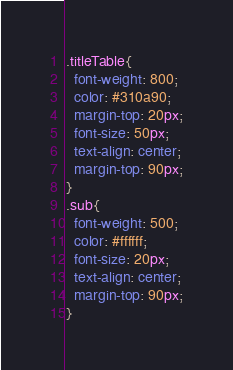<code> <loc_0><loc_0><loc_500><loc_500><_CSS_>.titleTable{
  font-weight: 800;
  color: #310a90;
  margin-top: 20px;
  font-size: 50px;
  text-align: center;
  margin-top: 90px;
}
.sub{
  font-weight: 500;
  color: #ffffff;
  font-size: 20px;
  text-align: center;
  margin-top: 90px;
}
</code> 